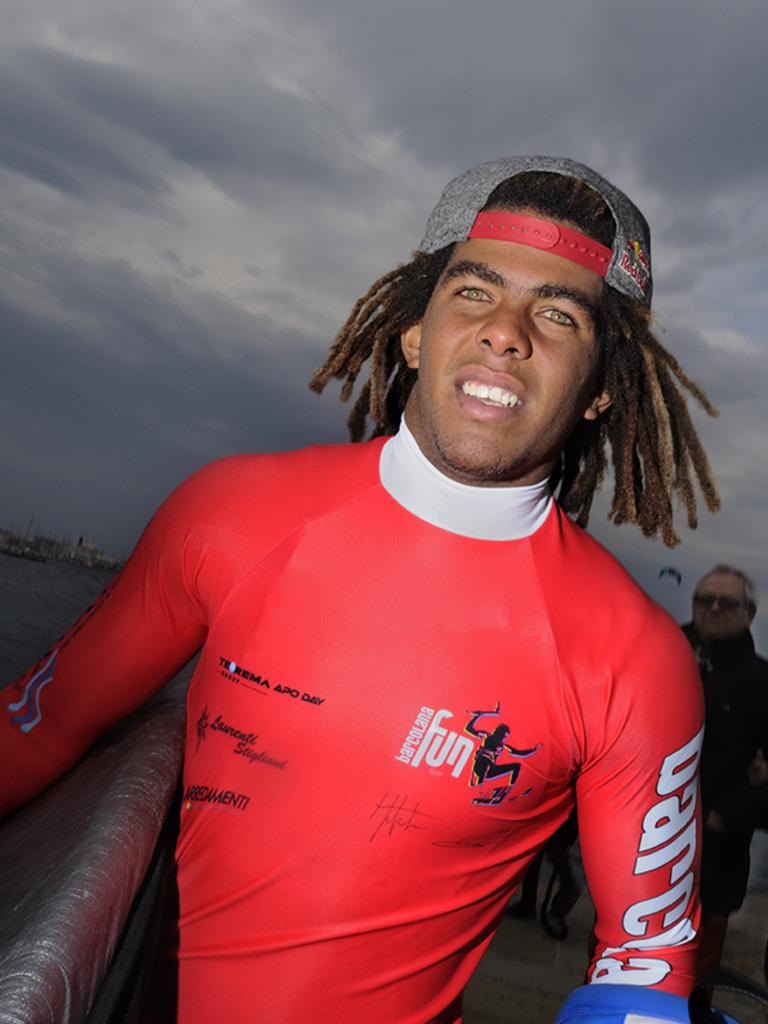What is the first letter of the word on the man's arm?
Your answer should be very brief. B. What is the white word on the mans chest?
Make the answer very short. Fun. 